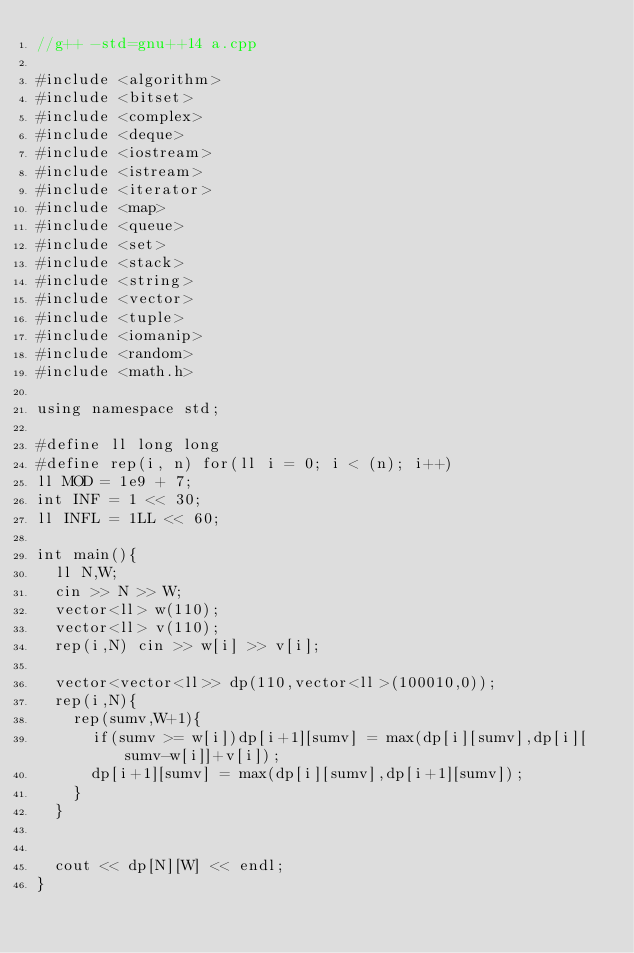<code> <loc_0><loc_0><loc_500><loc_500><_C++_>//g++ -std=gnu++14 a.cpp

#include <algorithm>
#include <bitset>
#include <complex>
#include <deque>
#include <iostream>
#include <istream>
#include <iterator>
#include <map>
#include <queue>
#include <set>
#include <stack>
#include <string>
#include <vector>
#include <tuple>
#include <iomanip>
#include <random>
#include <math.h>

using namespace std;

#define ll long long
#define rep(i, n) for(ll i = 0; i < (n); i++)
ll MOD = 1e9 + 7;
int INF = 1 << 30;
ll INFL = 1LL << 60;

int main(){
  ll N,W;
  cin >> N >> W;
  vector<ll> w(110);
  vector<ll> v(110);
  rep(i,N) cin >> w[i] >> v[i];

  vector<vector<ll>> dp(110,vector<ll>(100010,0));
  rep(i,N){
    rep(sumv,W+1){
      if(sumv >= w[i])dp[i+1][sumv] = max(dp[i][sumv],dp[i][sumv-w[i]]+v[i]);
      dp[i+1][sumv] = max(dp[i][sumv],dp[i+1][sumv]);
    }
  }


  cout << dp[N][W] << endl;
}
</code> 